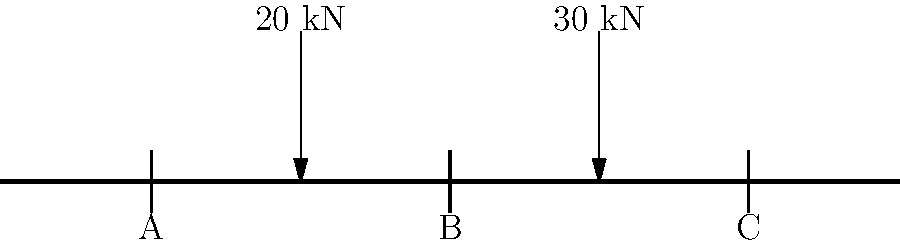A simply supported beam with three support points A, B, and C is subjected to two point loads as shown in the figure. The beam has a span of 6 meters with equal spacing between supports. Calculate the reaction forces at supports A, B, and C if the point loads are 20 kN at 1.5 m from support A and 30 kN at 1.5 m from support C. How does this load distribution relate to the concept of pitch selection in baseball? Let's approach this step-by-step:

1) First, we need to consider the equilibrium equations:
   $$\sum F_y = 0$$ (sum of vertical forces)
   $$\sum M = 0$$ (sum of moments)

2) Let's denote the reaction forces as $R_A$, $R_B$, and $R_C$.

3) From the vertical force equilibrium:
   $$R_A + R_B + R_C = 20 + 30 = 50 \text{ kN}$$

4) Taking moments about point A:
   $$3R_B + 6R_C - 20(1.5) - 30(4.5) = 0$$
   $$3R_B + 6R_C = 30 + 135 = 165$$

5) Taking moments about point C:
   $$6R_A + 3R_B - 20(4.5) - 30(1.5) = 0$$
   $$6R_A + 3R_B = 90 + 45 = 135$$

6) We now have three equations with three unknowns. Solving this system:
   $$R_A = 15 \text{ kN}$$
   $$R_B = 20 \text{ kN}$$
   $$R_C = 15 \text{ kN}$$

7) Relating to pitch selection in baseball:
   Just as a pitcher must distribute the load across different types of pitches to keep batters off-balance, this beam distributes the load across multiple support points. The middle support (B) takes the largest load, similar to how a pitcher's primary pitch often bears the "heaviest load" in their pitch selection. The outer supports (A and C) share the remaining load equally, much like how secondary pitches complement the primary one. Understanding load distribution in structures can help a pitcher visualize how to effectively distribute stress across different pitch types and locations to maintain control and prevent injury.
Answer: $R_A = 15 \text{ kN}, R_B = 20 \text{ kN}, R_C = 15 \text{ kN}$ 